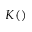Convert formula to latex. <formula><loc_0><loc_0><loc_500><loc_500>K ( )</formula> 